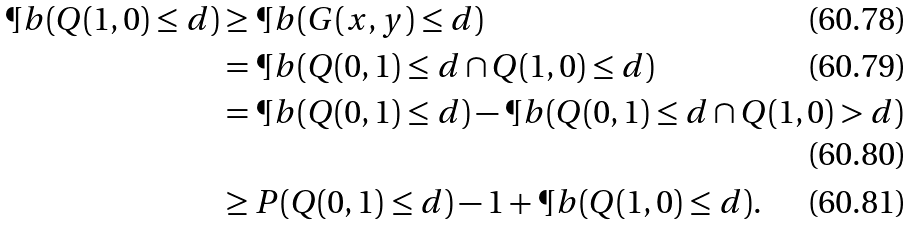Convert formula to latex. <formula><loc_0><loc_0><loc_500><loc_500>\P b ( Q ( 1 , 0 ) \leq d ) & \geq \P b ( G ( x , y ) \leq d ) \\ & = \P b ( Q ( 0 , 1 ) \leq d \cap Q ( 1 , 0 ) \leq d ) \\ & = \P b ( Q ( 0 , 1 ) \leq d ) - \P b ( Q ( 0 , 1 ) \leq d \cap Q ( 1 , 0 ) > d ) \\ & \geq P ( Q ( 0 , 1 ) \leq d ) - 1 + \P b ( Q ( 1 , 0 ) \leq d ) .</formula> 